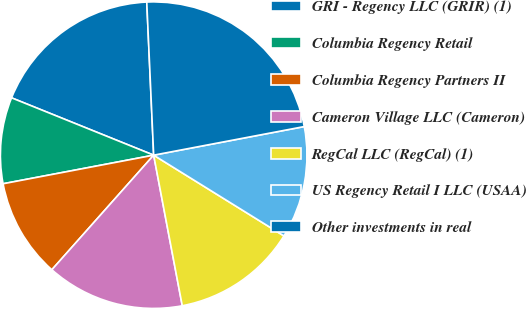Convert chart to OTSL. <chart><loc_0><loc_0><loc_500><loc_500><pie_chart><fcel>GRI - Regency LLC (GRIR) (1)<fcel>Columbia Regency Retail<fcel>Columbia Regency Partners II<fcel>Cameron Village LLC (Cameron)<fcel>RegCal LLC (RegCal) (1)<fcel>US Regency Retail I LLC (USAA)<fcel>Other investments in real<nl><fcel>18.18%<fcel>9.09%<fcel>10.45%<fcel>14.55%<fcel>13.18%<fcel>11.82%<fcel>22.73%<nl></chart> 